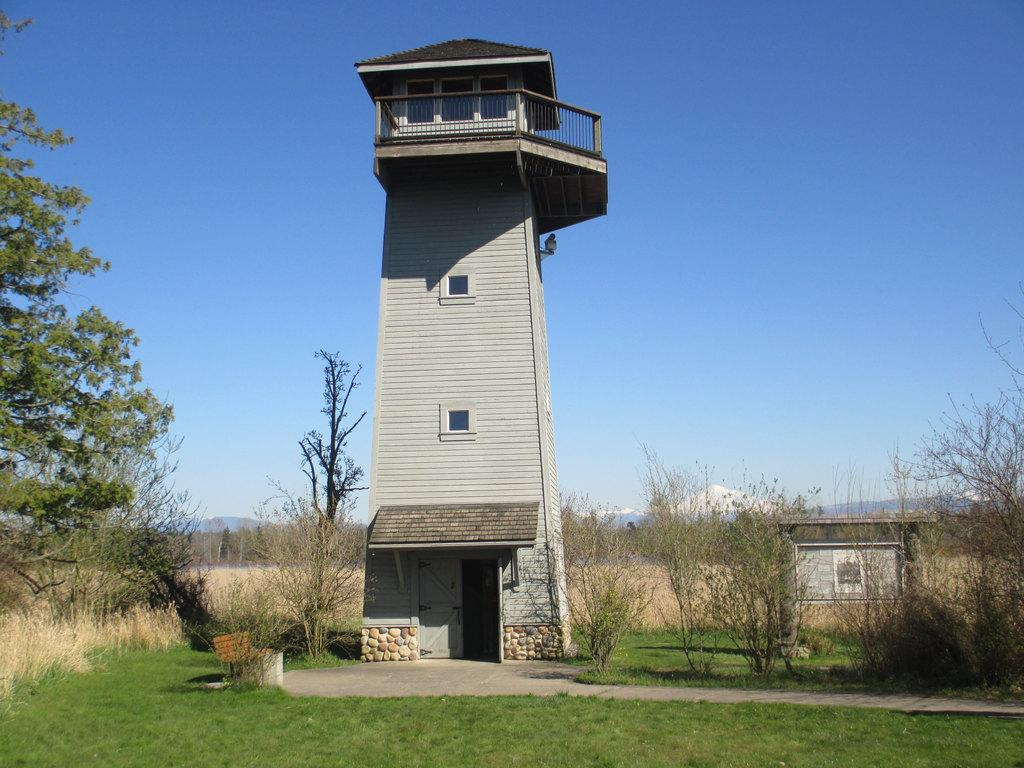What type of structure is in the image? There is a building in the image. What features can be seen on the building? The building has windows and pillars. What type of seating is present in the image? There is a bench in the image. What type of vegetation is present in the image? Grass, trees, and dried plants are visible in the image. What can be seen in the background of the image? There are mountains and the sky visible in the background of the image. How many tongues can be seen on the building in the image? There are no tongues present on the building in the image. What color are the eyes of the trees in the image? Trees do not have eyes, so this question cannot be answered. 